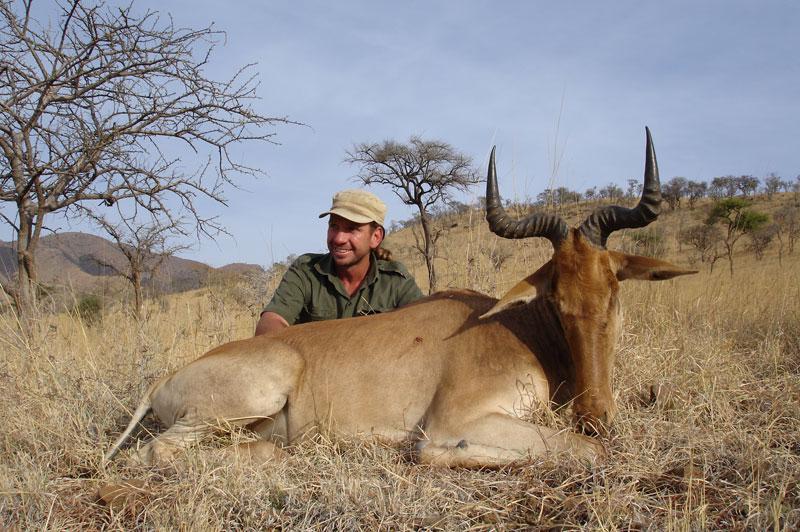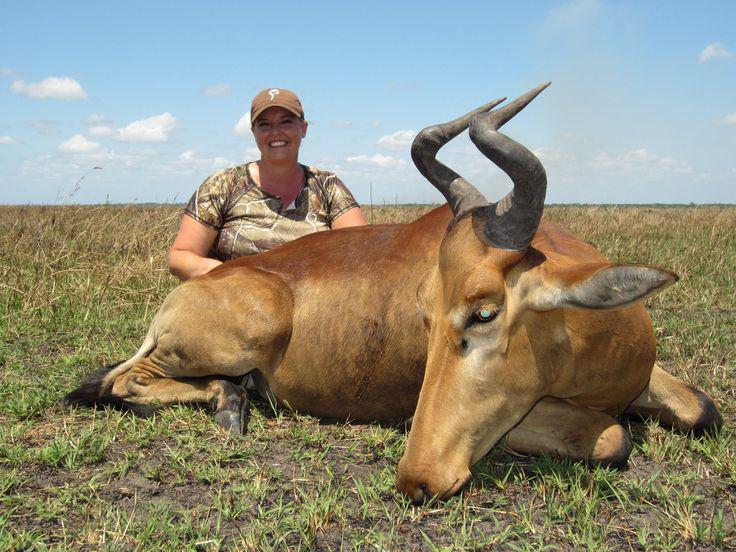The first image is the image on the left, the second image is the image on the right. Considering the images on both sides, is "One of the images has only one living creature." valid? Answer yes or no. No. The first image is the image on the left, the second image is the image on the right. For the images displayed, is the sentence "One image contains at least three times the number of hooved animals as the other image." factually correct? Answer yes or no. No. 